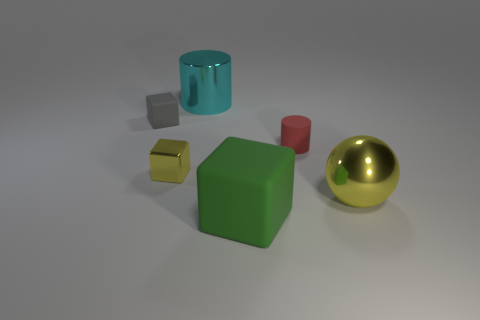Is there any other thing that is the same shape as the large yellow metal thing?
Your answer should be compact. No. There is a red matte cylinder; what number of green rubber things are on the left side of it?
Give a very brief answer. 1. Are there the same number of red matte things left of the red rubber object and large cyan metallic cylinders?
Your answer should be compact. No. Does the large cyan cylinder have the same material as the yellow sphere?
Offer a terse response. Yes. There is a object that is to the left of the small cylinder and right of the big shiny cylinder; how big is it?
Provide a succinct answer. Large. What number of metal cylinders are the same size as the yellow cube?
Keep it short and to the point. 0. What is the size of the rubber cube that is to the right of the block left of the small metal thing?
Your answer should be very brief. Large. Is the shape of the thing that is behind the small gray rubber cube the same as the rubber thing right of the green matte cube?
Offer a terse response. Yes. The big object that is left of the small red rubber cylinder and in front of the shiny cube is what color?
Offer a terse response. Green. Are there any tiny cubes that have the same color as the sphere?
Offer a terse response. Yes. 